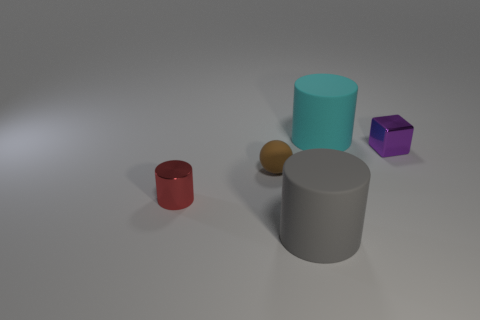Add 5 small cyan cubes. How many objects exist? 10 Subtract all big rubber cylinders. How many cylinders are left? 1 Subtract all red cylinders. How many cylinders are left? 2 Subtract 1 cylinders. How many cylinders are left? 2 Subtract all large cyan metallic things. Subtract all cylinders. How many objects are left? 2 Add 4 metal cylinders. How many metal cylinders are left? 5 Add 3 purple cubes. How many purple cubes exist? 4 Subtract 0 red cubes. How many objects are left? 5 Subtract all blocks. How many objects are left? 4 Subtract all yellow cylinders. Subtract all yellow balls. How many cylinders are left? 3 